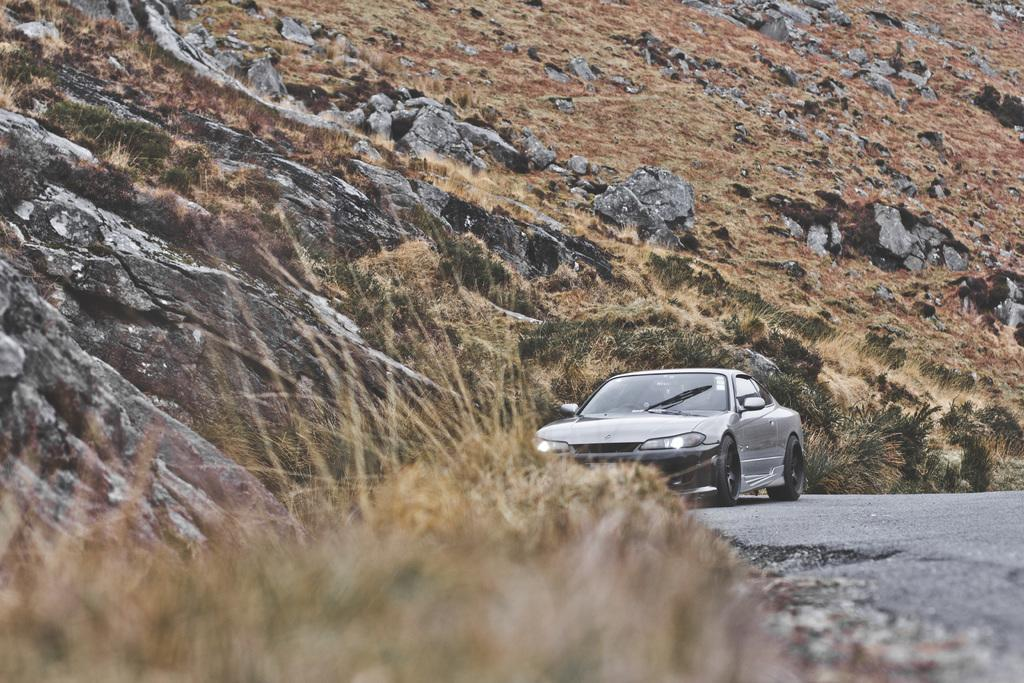What is the main subject of the image? There is a car on the road in the image. What can be seen in the background of the image? There is a mountain in the background of the image. What type of vegetation is present at the bottom of the image? There is dry grass at the bottom of the image. What type of jeans is the car wearing in the image? Cars do not wear jeans, as they are inanimate objects. 